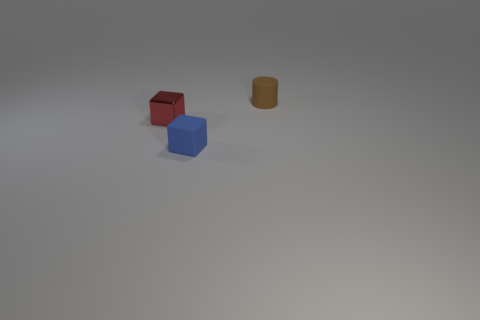Are there fewer small brown cylinders that are on the right side of the small brown rubber cylinder than tiny objects?
Your answer should be compact. Yes. How many tiny blue rubber things are there?
Give a very brief answer. 1. What number of small blue objects are made of the same material as the red thing?
Ensure brevity in your answer.  0. What number of objects are either matte objects that are in front of the tiny red shiny object or tiny blue rubber things?
Provide a succinct answer. 1. Are there fewer small matte blocks that are on the right side of the tiny blue rubber block than small metallic objects left of the small shiny object?
Keep it short and to the point. No. Are there any brown matte things in front of the red metallic cube?
Your response must be concise. No. What number of objects are small things that are in front of the brown matte object or small things in front of the red cube?
Provide a short and direct response. 2. What number of other tiny cubes have the same color as the metallic block?
Provide a succinct answer. 0. There is a tiny matte object that is the same shape as the small red metallic thing; what color is it?
Provide a succinct answer. Blue. What shape is the object that is both behind the tiny blue matte thing and right of the small red shiny block?
Make the answer very short. Cylinder. 